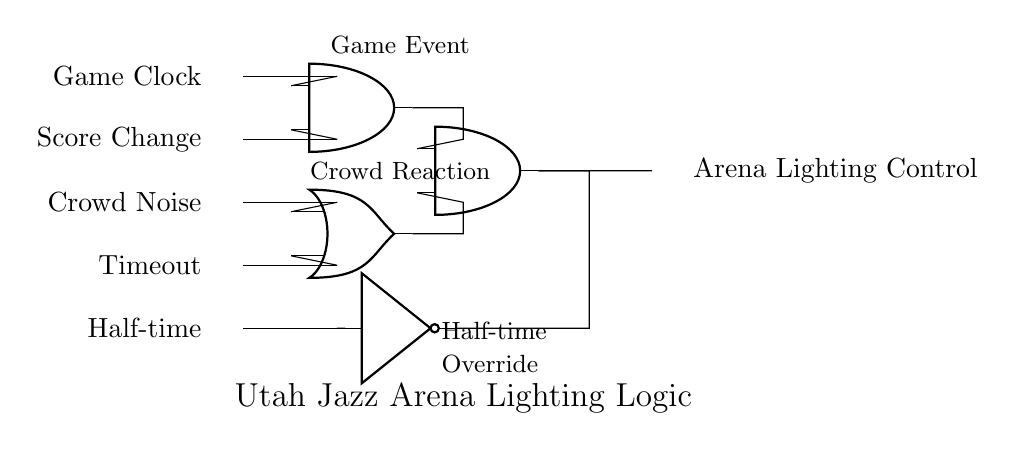What components are used in this logic gate system? The circuit diagram includes AND gates, OR gates, NOT gates, and input lines for various signals like Game Clock, Score Change, Crowd Noise, Timeout, and Half-time.
Answer: AND gates, OR gates, NOT gates What is the function of the AND gate in this circuit? The AND gate takes multiple inputs (Game Clock and Score Change) and outputs a signal indicating that both conditions are true, which is necessary for lighting control.
Answer: Both conditions must be true What happens when the Crowd Noise input goes high? If Crowd Noise is high, it will affect the input to the OR gate, which may result in a high output signal if either input to the OR gate is satisfied.
Answer: It may result in lighting activation How many inputs does the AND gate on the left have? The AND gate receives two inputs: Game Clock and Score Change. Both need to be high for the output to be high.
Answer: Two inputs What is the role of the NOT gate in the circuit? The NOT gate inverts the Half-time input, providing a low signal when Half-time is active. This ensures that lighting may still be controlled based on other conditions when it is Half-time.
Answer: Inverts the Half-time signal Which logic gate processes the Crowd Noise and Timeout signals? The OR gate processes the Crowd Noise and Timeout signals, producing a high output if at least one of its inputs is high.
Answer: OR gate 